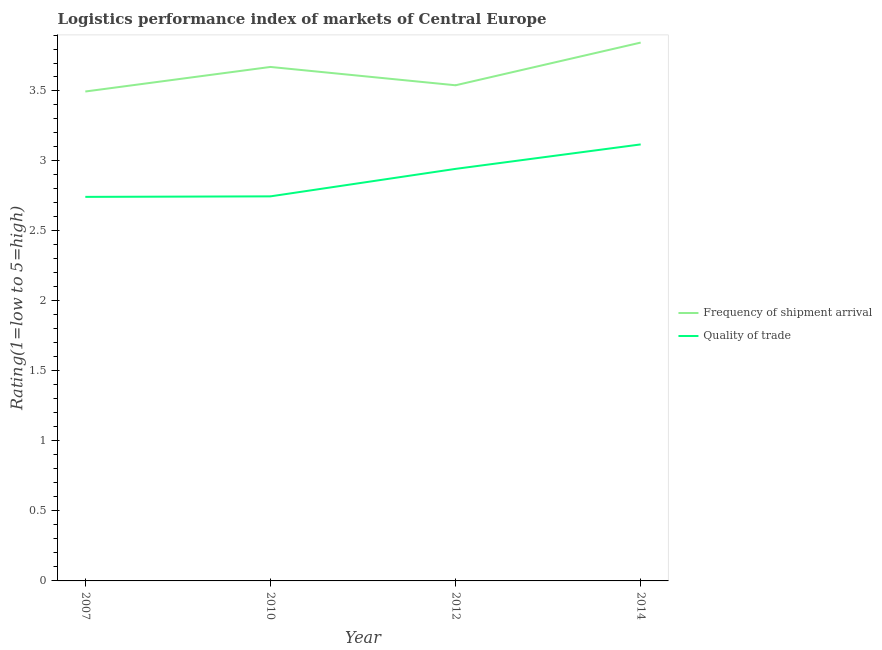Does the line corresponding to lpi of frequency of shipment arrival intersect with the line corresponding to lpi quality of trade?
Provide a succinct answer. No. What is the lpi of frequency of shipment arrival in 2012?
Offer a terse response. 3.54. Across all years, what is the maximum lpi of frequency of shipment arrival?
Your answer should be very brief. 3.85. Across all years, what is the minimum lpi of frequency of shipment arrival?
Your answer should be compact. 3.5. In which year was the lpi of frequency of shipment arrival minimum?
Make the answer very short. 2007. What is the total lpi of frequency of shipment arrival in the graph?
Keep it short and to the point. 14.55. What is the difference between the lpi of frequency of shipment arrival in 2007 and that in 2010?
Offer a terse response. -0.18. What is the difference between the lpi of frequency of shipment arrival in 2012 and the lpi quality of trade in 2007?
Your answer should be very brief. 0.8. What is the average lpi quality of trade per year?
Keep it short and to the point. 2.89. In the year 2007, what is the difference between the lpi quality of trade and lpi of frequency of shipment arrival?
Offer a very short reply. -0.75. What is the ratio of the lpi quality of trade in 2012 to that in 2014?
Provide a succinct answer. 0.94. Is the lpi quality of trade in 2007 less than that in 2010?
Your answer should be very brief. Yes. Is the difference between the lpi quality of trade in 2007 and 2014 greater than the difference between the lpi of frequency of shipment arrival in 2007 and 2014?
Your response must be concise. No. What is the difference between the highest and the second highest lpi quality of trade?
Keep it short and to the point. 0.17. What is the difference between the highest and the lowest lpi quality of trade?
Make the answer very short. 0.37. In how many years, is the lpi of frequency of shipment arrival greater than the average lpi of frequency of shipment arrival taken over all years?
Ensure brevity in your answer.  2. Is the lpi of frequency of shipment arrival strictly less than the lpi quality of trade over the years?
Give a very brief answer. No. How many lines are there?
Make the answer very short. 2. How many years are there in the graph?
Make the answer very short. 4. Are the values on the major ticks of Y-axis written in scientific E-notation?
Give a very brief answer. No. Does the graph contain grids?
Your response must be concise. No. Where does the legend appear in the graph?
Make the answer very short. Center right. What is the title of the graph?
Ensure brevity in your answer.  Logistics performance index of markets of Central Europe. What is the label or title of the X-axis?
Ensure brevity in your answer.  Year. What is the label or title of the Y-axis?
Offer a very short reply. Rating(1=low to 5=high). What is the Rating(1=low to 5=high) in Frequency of shipment arrival in 2007?
Provide a succinct answer. 3.5. What is the Rating(1=low to 5=high) of Quality of trade in 2007?
Provide a succinct answer. 2.74. What is the Rating(1=low to 5=high) of Frequency of shipment arrival in 2010?
Provide a short and direct response. 3.67. What is the Rating(1=low to 5=high) of Quality of trade in 2010?
Offer a terse response. 2.75. What is the Rating(1=low to 5=high) of Frequency of shipment arrival in 2012?
Your answer should be compact. 3.54. What is the Rating(1=low to 5=high) of Quality of trade in 2012?
Give a very brief answer. 2.94. What is the Rating(1=low to 5=high) of Frequency of shipment arrival in 2014?
Keep it short and to the point. 3.85. What is the Rating(1=low to 5=high) in Quality of trade in 2014?
Provide a succinct answer. 3.12. Across all years, what is the maximum Rating(1=low to 5=high) of Frequency of shipment arrival?
Ensure brevity in your answer.  3.85. Across all years, what is the maximum Rating(1=low to 5=high) of Quality of trade?
Provide a succinct answer. 3.12. Across all years, what is the minimum Rating(1=low to 5=high) in Frequency of shipment arrival?
Provide a succinct answer. 3.5. Across all years, what is the minimum Rating(1=low to 5=high) of Quality of trade?
Ensure brevity in your answer.  2.74. What is the total Rating(1=low to 5=high) in Frequency of shipment arrival in the graph?
Provide a succinct answer. 14.55. What is the total Rating(1=low to 5=high) in Quality of trade in the graph?
Keep it short and to the point. 11.55. What is the difference between the Rating(1=low to 5=high) in Frequency of shipment arrival in 2007 and that in 2010?
Provide a succinct answer. -0.18. What is the difference between the Rating(1=low to 5=high) in Quality of trade in 2007 and that in 2010?
Your response must be concise. -0. What is the difference between the Rating(1=low to 5=high) of Frequency of shipment arrival in 2007 and that in 2012?
Offer a very short reply. -0.04. What is the difference between the Rating(1=low to 5=high) in Quality of trade in 2007 and that in 2012?
Your response must be concise. -0.2. What is the difference between the Rating(1=low to 5=high) of Frequency of shipment arrival in 2007 and that in 2014?
Give a very brief answer. -0.35. What is the difference between the Rating(1=low to 5=high) of Quality of trade in 2007 and that in 2014?
Your response must be concise. -0.37. What is the difference between the Rating(1=low to 5=high) in Frequency of shipment arrival in 2010 and that in 2012?
Offer a terse response. 0.13. What is the difference between the Rating(1=low to 5=high) in Quality of trade in 2010 and that in 2012?
Give a very brief answer. -0.2. What is the difference between the Rating(1=low to 5=high) of Frequency of shipment arrival in 2010 and that in 2014?
Give a very brief answer. -0.17. What is the difference between the Rating(1=low to 5=high) in Quality of trade in 2010 and that in 2014?
Your answer should be compact. -0.37. What is the difference between the Rating(1=low to 5=high) of Frequency of shipment arrival in 2012 and that in 2014?
Ensure brevity in your answer.  -0.3. What is the difference between the Rating(1=low to 5=high) in Quality of trade in 2012 and that in 2014?
Give a very brief answer. -0.17. What is the difference between the Rating(1=low to 5=high) in Frequency of shipment arrival in 2007 and the Rating(1=low to 5=high) in Quality of trade in 2010?
Make the answer very short. 0.75. What is the difference between the Rating(1=low to 5=high) of Frequency of shipment arrival in 2007 and the Rating(1=low to 5=high) of Quality of trade in 2012?
Give a very brief answer. 0.55. What is the difference between the Rating(1=low to 5=high) in Frequency of shipment arrival in 2007 and the Rating(1=low to 5=high) in Quality of trade in 2014?
Your answer should be very brief. 0.38. What is the difference between the Rating(1=low to 5=high) of Frequency of shipment arrival in 2010 and the Rating(1=low to 5=high) of Quality of trade in 2012?
Give a very brief answer. 0.73. What is the difference between the Rating(1=low to 5=high) in Frequency of shipment arrival in 2010 and the Rating(1=low to 5=high) in Quality of trade in 2014?
Provide a short and direct response. 0.55. What is the difference between the Rating(1=low to 5=high) of Frequency of shipment arrival in 2012 and the Rating(1=low to 5=high) of Quality of trade in 2014?
Ensure brevity in your answer.  0.42. What is the average Rating(1=low to 5=high) in Frequency of shipment arrival per year?
Provide a short and direct response. 3.64. What is the average Rating(1=low to 5=high) of Quality of trade per year?
Provide a succinct answer. 2.89. In the year 2007, what is the difference between the Rating(1=low to 5=high) in Frequency of shipment arrival and Rating(1=low to 5=high) in Quality of trade?
Offer a terse response. 0.75. In the year 2010, what is the difference between the Rating(1=low to 5=high) of Frequency of shipment arrival and Rating(1=low to 5=high) of Quality of trade?
Make the answer very short. 0.92. In the year 2012, what is the difference between the Rating(1=low to 5=high) in Frequency of shipment arrival and Rating(1=low to 5=high) in Quality of trade?
Your response must be concise. 0.6. In the year 2014, what is the difference between the Rating(1=low to 5=high) in Frequency of shipment arrival and Rating(1=low to 5=high) in Quality of trade?
Provide a short and direct response. 0.73. What is the ratio of the Rating(1=low to 5=high) in Frequency of shipment arrival in 2007 to that in 2010?
Your answer should be compact. 0.95. What is the ratio of the Rating(1=low to 5=high) of Frequency of shipment arrival in 2007 to that in 2012?
Offer a terse response. 0.99. What is the ratio of the Rating(1=low to 5=high) of Quality of trade in 2007 to that in 2012?
Provide a short and direct response. 0.93. What is the ratio of the Rating(1=low to 5=high) of Frequency of shipment arrival in 2007 to that in 2014?
Provide a short and direct response. 0.91. What is the ratio of the Rating(1=low to 5=high) in Quality of trade in 2007 to that in 2014?
Provide a short and direct response. 0.88. What is the ratio of the Rating(1=low to 5=high) of Frequency of shipment arrival in 2010 to that in 2014?
Keep it short and to the point. 0.95. What is the ratio of the Rating(1=low to 5=high) of Quality of trade in 2010 to that in 2014?
Make the answer very short. 0.88. What is the ratio of the Rating(1=low to 5=high) in Frequency of shipment arrival in 2012 to that in 2014?
Provide a succinct answer. 0.92. What is the ratio of the Rating(1=low to 5=high) of Quality of trade in 2012 to that in 2014?
Keep it short and to the point. 0.94. What is the difference between the highest and the second highest Rating(1=low to 5=high) in Frequency of shipment arrival?
Your response must be concise. 0.17. What is the difference between the highest and the second highest Rating(1=low to 5=high) in Quality of trade?
Keep it short and to the point. 0.17. What is the difference between the highest and the lowest Rating(1=low to 5=high) of Frequency of shipment arrival?
Make the answer very short. 0.35. What is the difference between the highest and the lowest Rating(1=low to 5=high) in Quality of trade?
Provide a succinct answer. 0.37. 